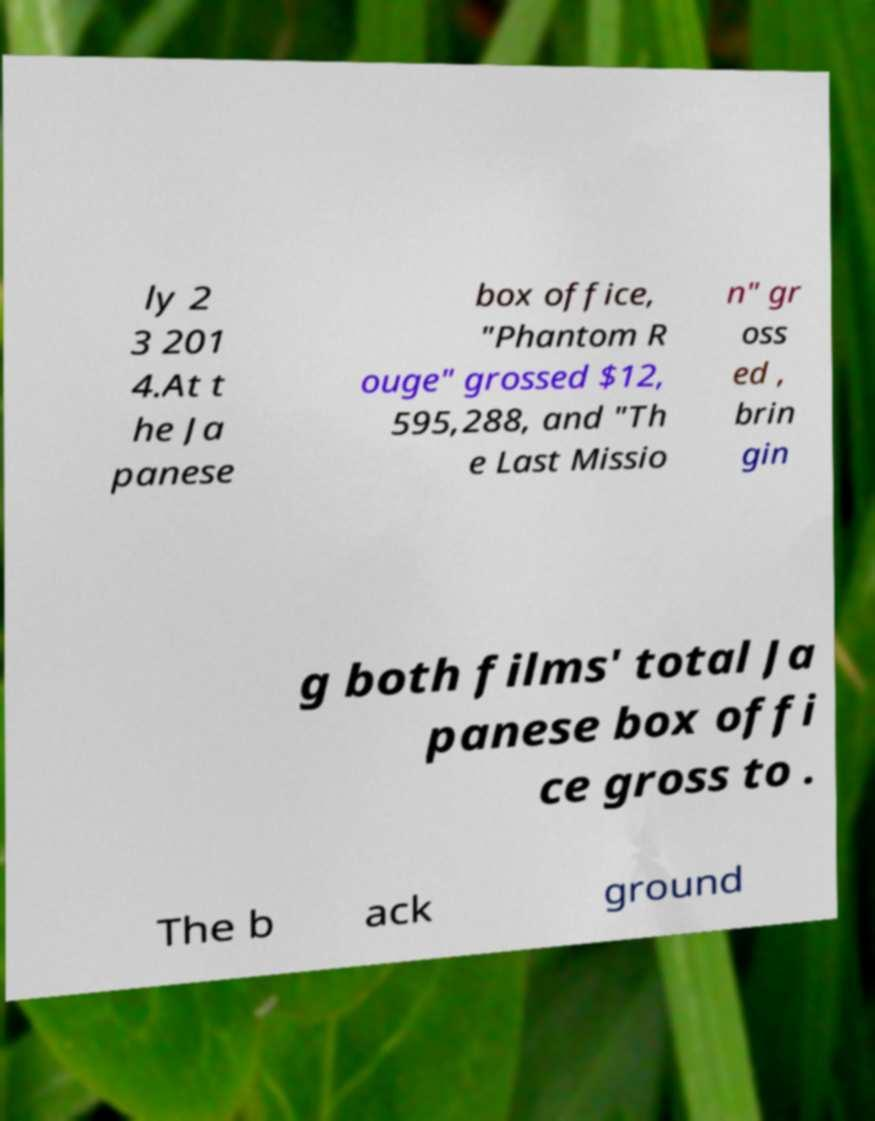Can you read and provide the text displayed in the image?This photo seems to have some interesting text. Can you extract and type it out for me? ly 2 3 201 4.At t he Ja panese box office, "Phantom R ouge" grossed $12, 595,288, and "Th e Last Missio n" gr oss ed , brin gin g both films' total Ja panese box offi ce gross to . The b ack ground 